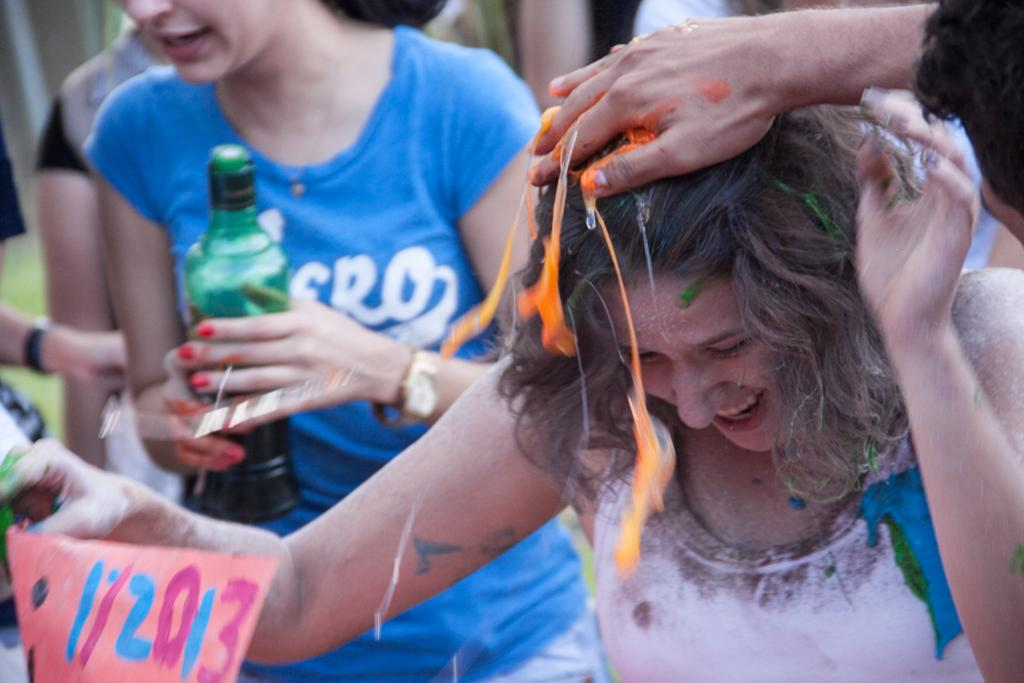What is the lady in the white dress wearing in the image? The lady in the white dress is wearing a white dress in the image. What is the lady in the white dress doing? The lady in the white dress is smiling and holding a paper in the image. What is the lady in the blue dress wearing in the image? The lady in the blue dress is wearing a blue dress in the image. What is the lady in the blue dress holding in the image? The lady in the blue dress is holding a bottle in the image. What accessory is the lady in the blue dress wearing in the image? The lady in the blue dress is wearing a watch in the image. What type of popcorn is the actor eating in the image? There is no actor or popcorn present in the image. 